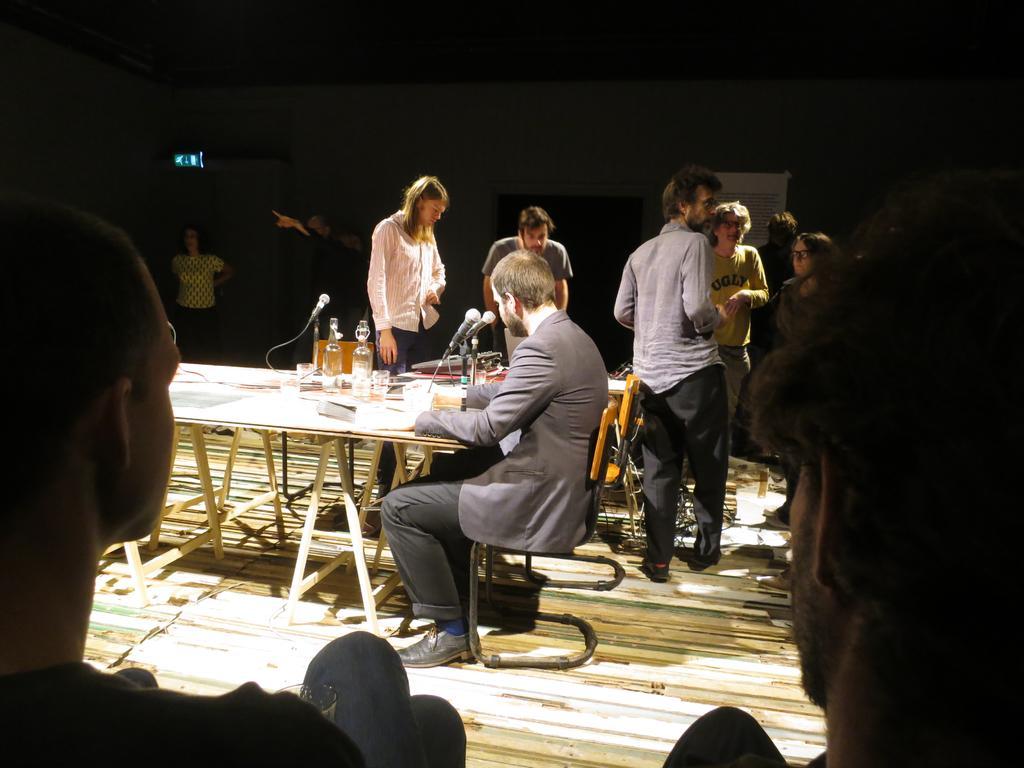Please provide a concise description of this image. In this image their is a man who is sitting on the chair and table in front of him. On the table there are mice,glasses,cups. At the background there are people who are standing around the table. There are chairs in the middle of people. 